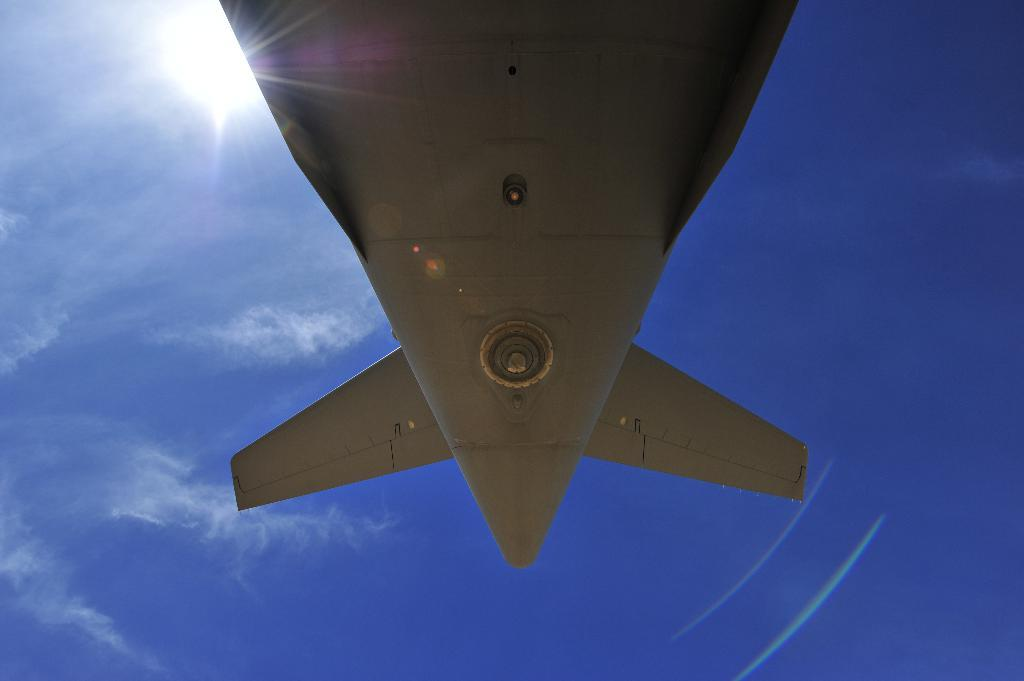What is the main subject of the image? There is an aircraft in the image. What can be seen in the background of the image? The sky is visible in the background of the image. Are there any weather conditions visible in the image? Yes, clouds are present in the sky. Where is the desk located in the image? There is no desk present in the image. Is there a bed visible in the image? No, there is no bed visible in the image. Are there any books in the image? There are no books visible in the image. 